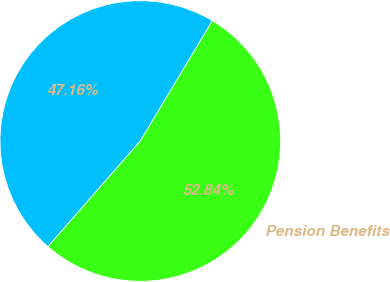Convert chart. <chart><loc_0><loc_0><loc_500><loc_500><pie_chart><ecel><fcel>Pension Benefits<nl><fcel>47.16%<fcel>52.84%<nl></chart> 